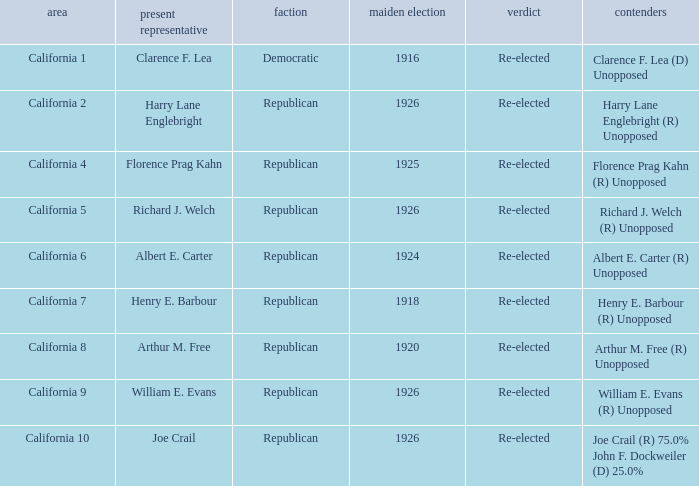What's the district with incumbent being richard j. welch California 5. 